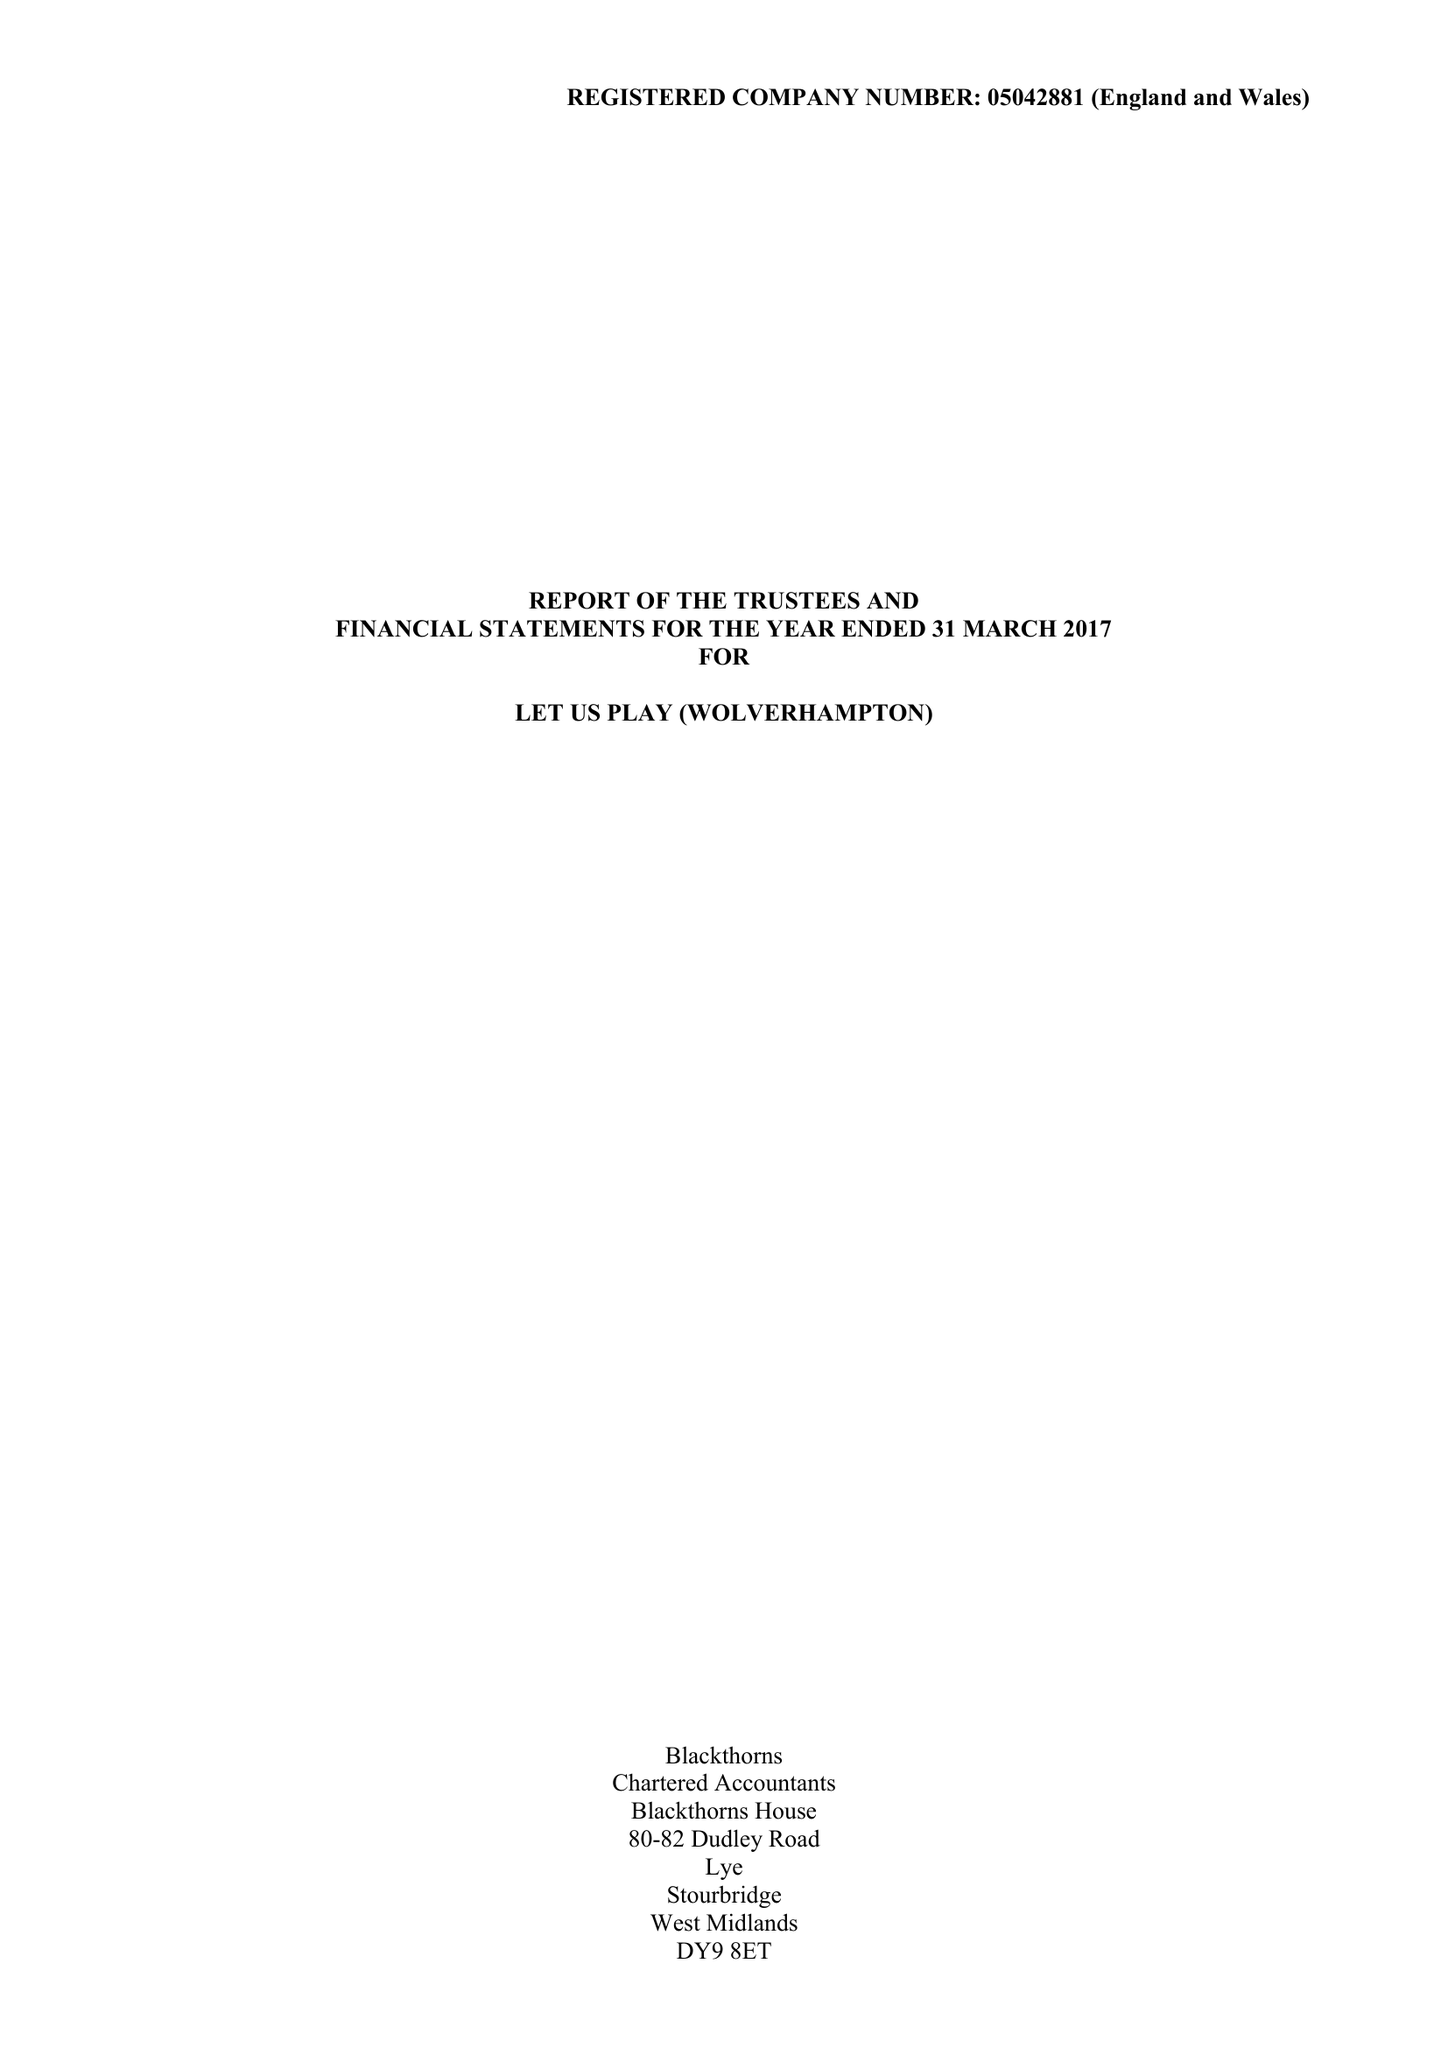What is the value for the address__postcode?
Answer the question using a single word or phrase. WV10 9LE 